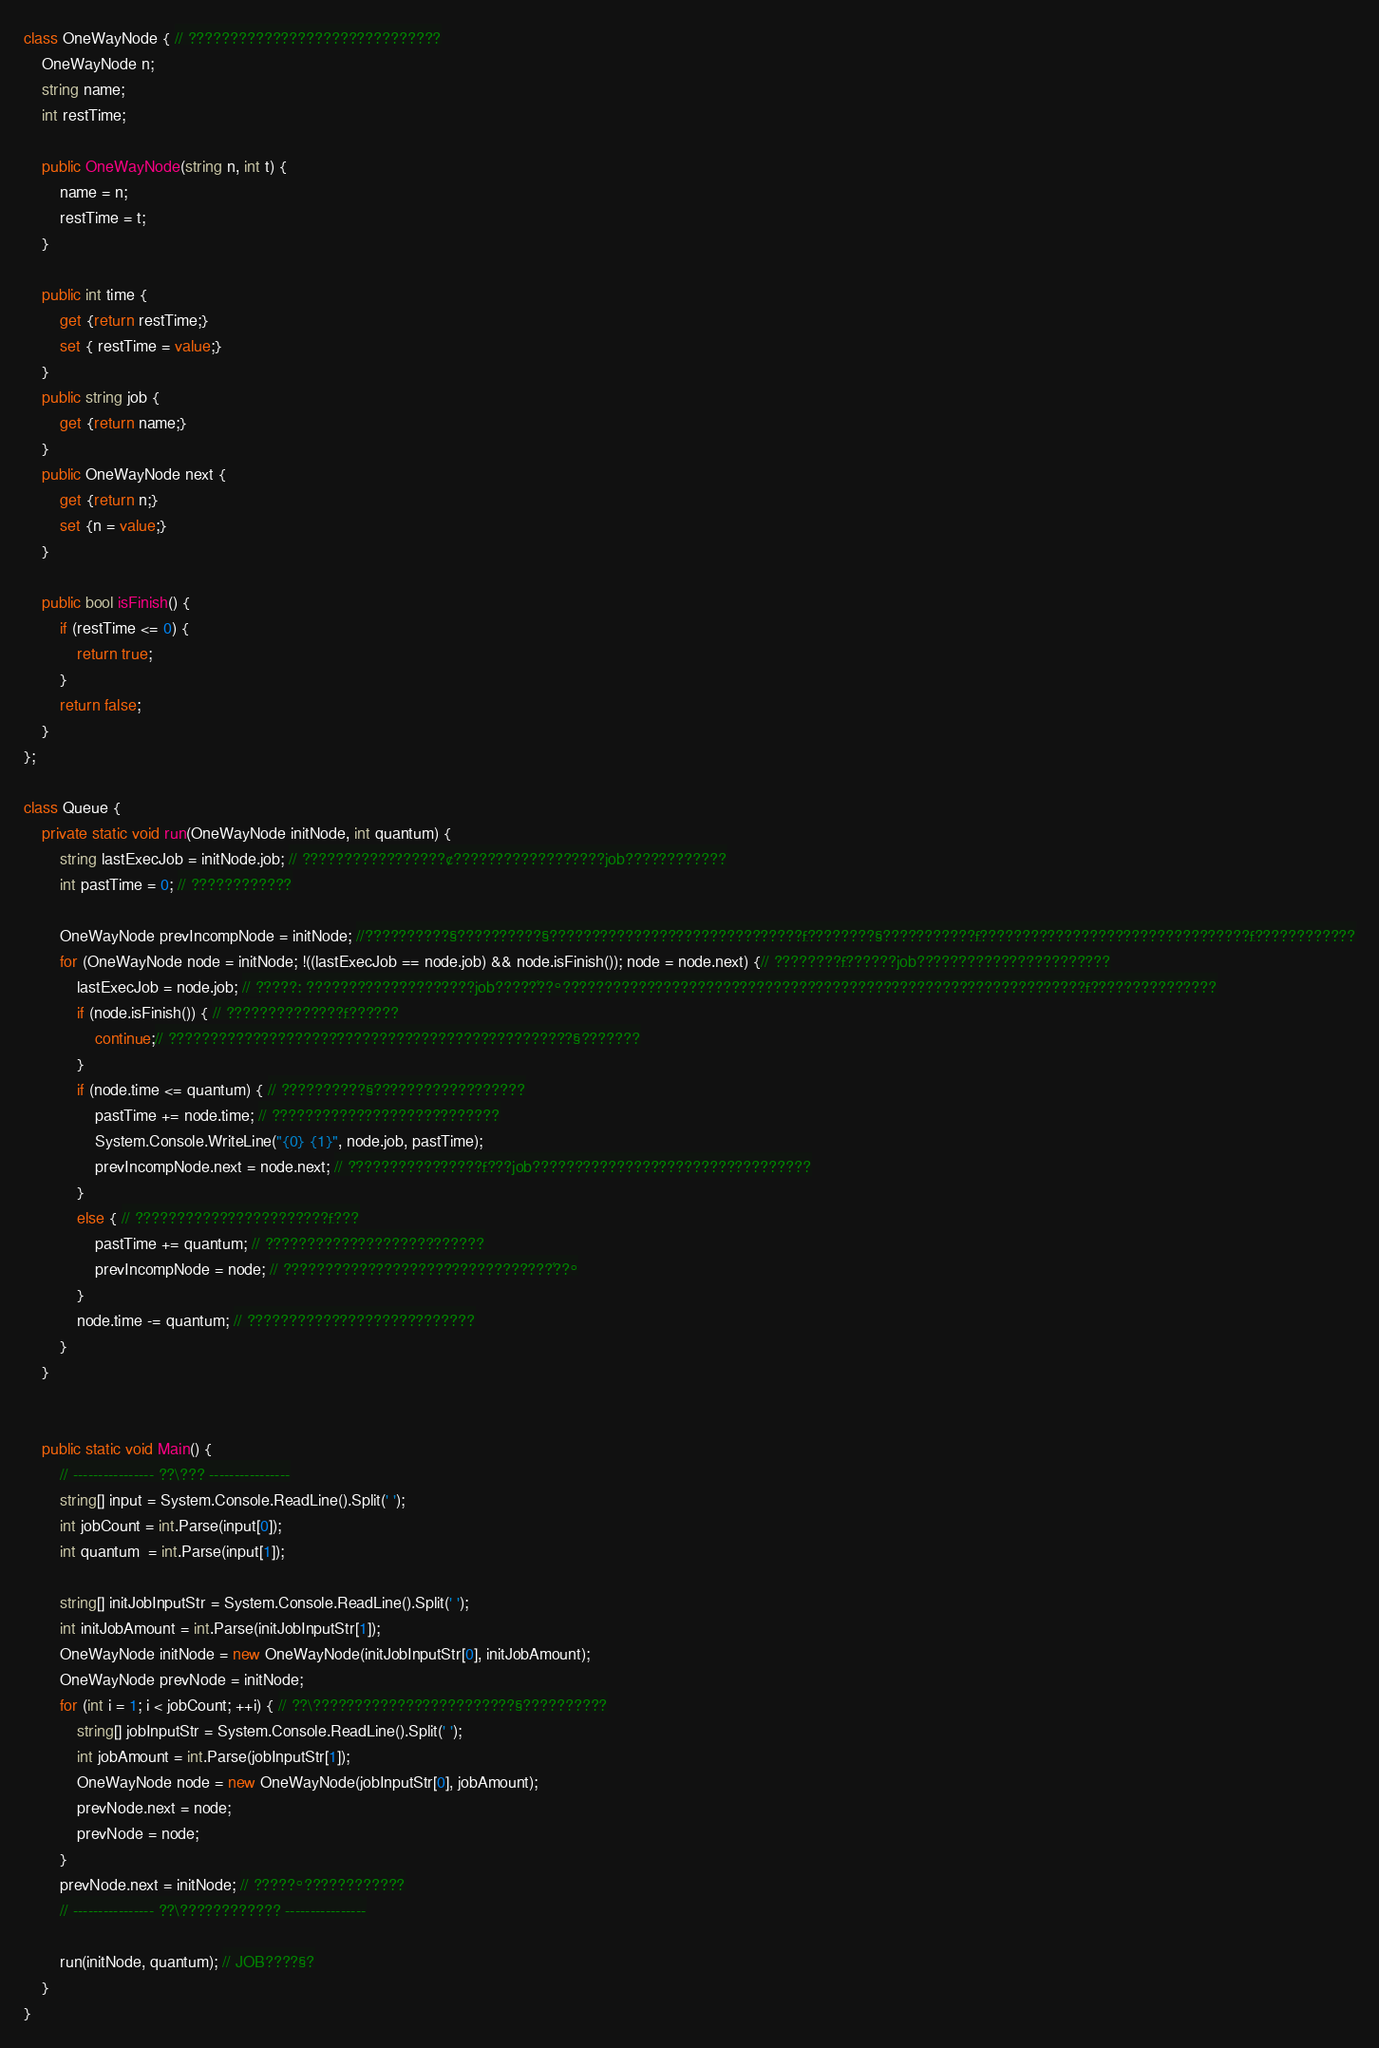<code> <loc_0><loc_0><loc_500><loc_500><_C#_>class OneWayNode { // ??????????????????????????????
    OneWayNode n;
	string name;
	int restTime;
	
	public OneWayNode(string n, int t) {
		name = n;
		restTime = t;
	}
	
	public int time {
		get {return restTime;}
		set { restTime = value;}
	}
	public string job {
		get {return name;}
	}
	public OneWayNode next {
		get {return n;}
		set {n = value;}
	}
	
	public bool isFinish() {
		if (restTime <= 0) {
			return true;
		}
		return false;
	}
};

class Queue {
	private static void run(OneWayNode initNode, int quantum) {
		string lastExecJob = initNode.job; // ?????????????????¢??????????????????job????????????
		int pastTime = 0; // ????????????
		
		OneWayNode prevIncompNode = initNode; //?¨?????????§??????????§??????????????????????????????£????????§???????????£????????????????????????????????£????????????
		for (OneWayNode node = initNode; !((lastExecJob == node.job) && node.isFinish()); node = node.next) {// ????????£??????job?????¨??????????????????
			lastExecJob = node.job; // ?¨????: ???????????¨?????????job?????´??°??????????????????????????????????????????????????????????????£???????????????
			if (node.isFinish()) { // ??????????????£??????
				continue;// ????????????????????¨????????????????????????????§???????
			}
			if (node.time <= quantum) { // ????????¨??§??????????????????
				pastTime += node.time; // ???????????????????????????
				System.Console.WriteLine("{0} {1}", node.job, pastTime);
				prevIncompNode.next = node.next; // ?¨???????????????£???job?????????????????????????????????
			}
			else { // ???????????????????????£???
				pastTime += quantum; // ??¨????????????????????????
				prevIncompNode = node; // ????????????????????????????????´??°
			}
			node.time -= quantum; // ???????????????????????????
		}
	}
	
	
	public static void Main() {
		// ---------------- ??\??? ----------------
		string[] input = System.Console.ReadLine().Split(' ');
		int jobCount = int.Parse(input[0]);
		int quantum  = int.Parse(input[1]);
		
		string[] initJobInputStr = System.Console.ReadLine().Split(' ');
		int initJobAmount = int.Parse(initJobInputStr[1]);
		OneWayNode initNode = new OneWayNode(initJobInputStr[0], initJobAmount);
		OneWayNode prevNode = initNode;
		for (int i = 1; i < jobCount; ++i) { // ??\?????¨???????????????????§??????????
			string[] jobInputStr = System.Console.ReadLine().Split(' ');
			int jobAmount = int.Parse(jobInputStr[1]);
			OneWayNode node = new OneWayNode(jobInputStr[0], jobAmount);
			prevNode.next = node;
			prevNode = node;
		}
		prevNode.next = initNode; // ?????°????????????
		// ---------------- ??\???????????? ----------------
		
		run(initNode, quantum); // JOB????§?
	}
}</code> 